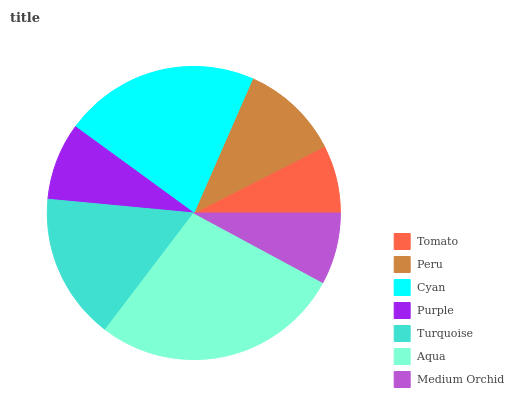Is Tomato the minimum?
Answer yes or no. Yes. Is Aqua the maximum?
Answer yes or no. Yes. Is Peru the minimum?
Answer yes or no. No. Is Peru the maximum?
Answer yes or no. No. Is Peru greater than Tomato?
Answer yes or no. Yes. Is Tomato less than Peru?
Answer yes or no. Yes. Is Tomato greater than Peru?
Answer yes or no. No. Is Peru less than Tomato?
Answer yes or no. No. Is Peru the high median?
Answer yes or no. Yes. Is Peru the low median?
Answer yes or no. Yes. Is Cyan the high median?
Answer yes or no. No. Is Turquoise the low median?
Answer yes or no. No. 